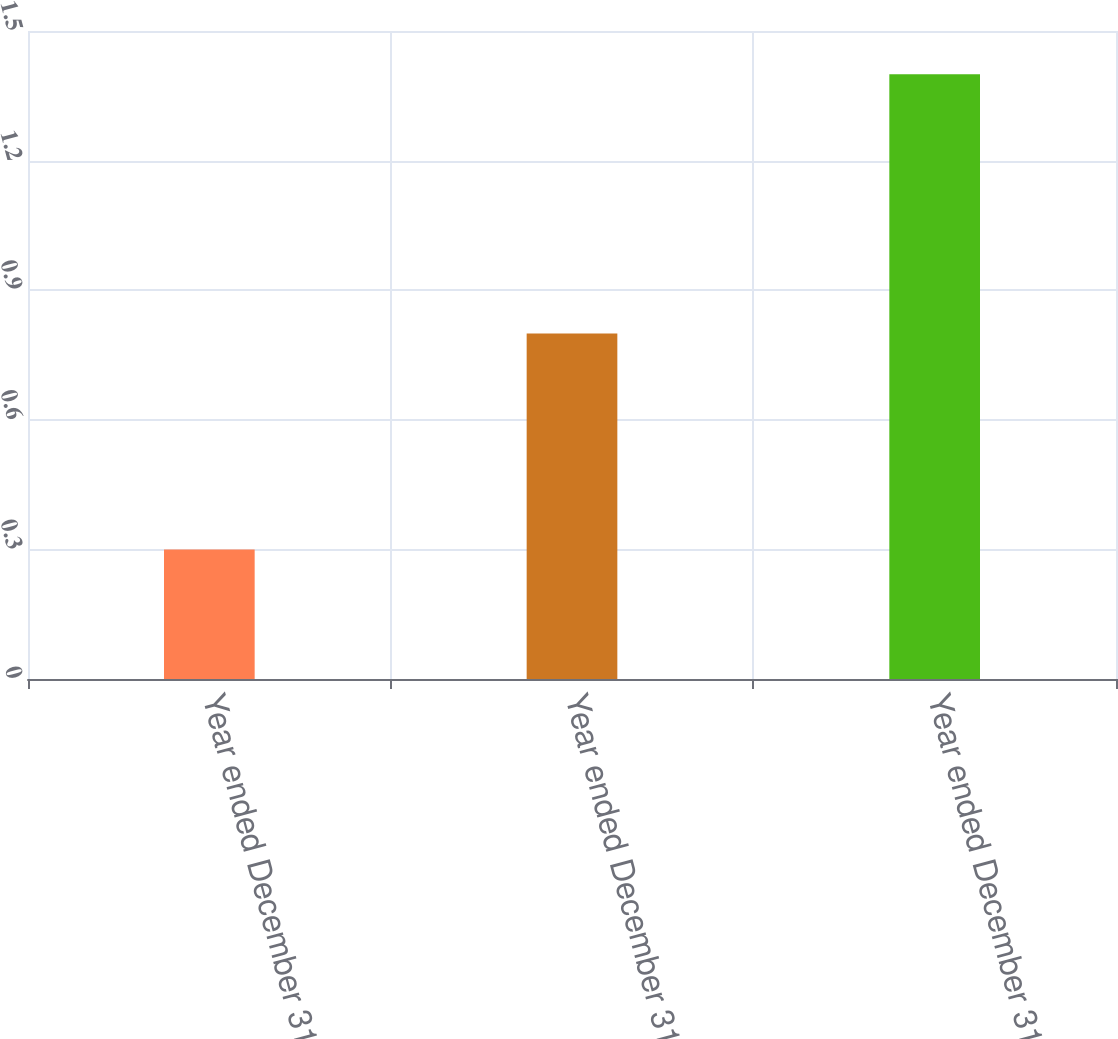Convert chart to OTSL. <chart><loc_0><loc_0><loc_500><loc_500><bar_chart><fcel>Year ended December 31 2016<fcel>Year ended December 31 2015<fcel>Year ended December 31 2014<nl><fcel>0.3<fcel>0.8<fcel>1.4<nl></chart> 